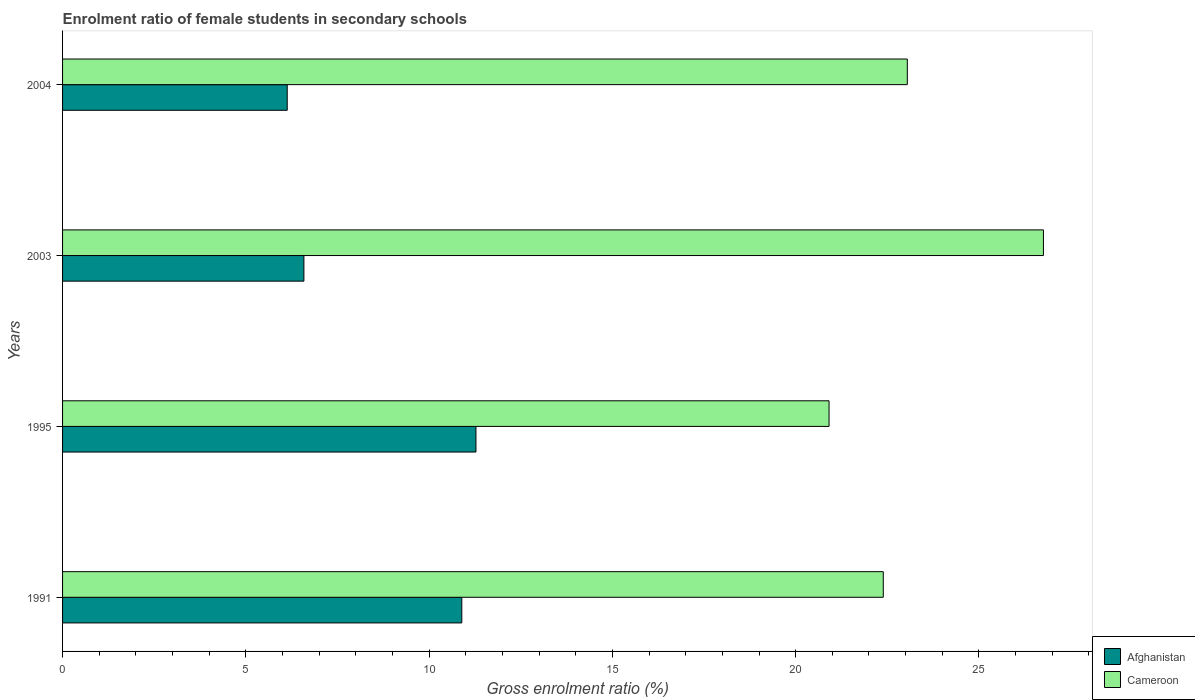How many bars are there on the 3rd tick from the top?
Give a very brief answer. 2. How many bars are there on the 2nd tick from the bottom?
Offer a very short reply. 2. In how many cases, is the number of bars for a given year not equal to the number of legend labels?
Offer a terse response. 0. What is the enrolment ratio of female students in secondary schools in Afghanistan in 1995?
Your answer should be compact. 11.28. Across all years, what is the maximum enrolment ratio of female students in secondary schools in Cameroon?
Keep it short and to the point. 26.76. Across all years, what is the minimum enrolment ratio of female students in secondary schools in Cameroon?
Your answer should be compact. 20.91. What is the total enrolment ratio of female students in secondary schools in Afghanistan in the graph?
Offer a very short reply. 34.88. What is the difference between the enrolment ratio of female students in secondary schools in Cameroon in 1991 and that in 2003?
Ensure brevity in your answer.  -4.37. What is the difference between the enrolment ratio of female students in secondary schools in Afghanistan in 2004 and the enrolment ratio of female students in secondary schools in Cameroon in 1991?
Provide a short and direct response. -16.26. What is the average enrolment ratio of female students in secondary schools in Cameroon per year?
Make the answer very short. 23.28. In the year 2003, what is the difference between the enrolment ratio of female students in secondary schools in Afghanistan and enrolment ratio of female students in secondary schools in Cameroon?
Provide a succinct answer. -20.18. In how many years, is the enrolment ratio of female students in secondary schools in Afghanistan greater than 13 %?
Ensure brevity in your answer.  0. What is the ratio of the enrolment ratio of female students in secondary schools in Afghanistan in 1991 to that in 2004?
Give a very brief answer. 1.78. Is the enrolment ratio of female students in secondary schools in Afghanistan in 1991 less than that in 2003?
Offer a terse response. No. What is the difference between the highest and the second highest enrolment ratio of female students in secondary schools in Afghanistan?
Your response must be concise. 0.39. What is the difference between the highest and the lowest enrolment ratio of female students in secondary schools in Afghanistan?
Offer a very short reply. 5.15. In how many years, is the enrolment ratio of female students in secondary schools in Afghanistan greater than the average enrolment ratio of female students in secondary schools in Afghanistan taken over all years?
Provide a short and direct response. 2. Is the sum of the enrolment ratio of female students in secondary schools in Cameroon in 1991 and 1995 greater than the maximum enrolment ratio of female students in secondary schools in Afghanistan across all years?
Your response must be concise. Yes. What does the 2nd bar from the top in 2003 represents?
Provide a succinct answer. Afghanistan. What does the 2nd bar from the bottom in 1995 represents?
Keep it short and to the point. Cameroon. How many bars are there?
Provide a succinct answer. 8. How many years are there in the graph?
Your response must be concise. 4. Does the graph contain grids?
Offer a very short reply. No. Where does the legend appear in the graph?
Give a very brief answer. Bottom right. What is the title of the graph?
Your answer should be very brief. Enrolment ratio of female students in secondary schools. What is the label or title of the Y-axis?
Ensure brevity in your answer.  Years. What is the Gross enrolment ratio (%) of Afghanistan in 1991?
Your answer should be very brief. 10.89. What is the Gross enrolment ratio (%) in Cameroon in 1991?
Your answer should be compact. 22.39. What is the Gross enrolment ratio (%) in Afghanistan in 1995?
Your response must be concise. 11.28. What is the Gross enrolment ratio (%) in Cameroon in 1995?
Ensure brevity in your answer.  20.91. What is the Gross enrolment ratio (%) in Afghanistan in 2003?
Give a very brief answer. 6.58. What is the Gross enrolment ratio (%) of Cameroon in 2003?
Provide a succinct answer. 26.76. What is the Gross enrolment ratio (%) in Afghanistan in 2004?
Your response must be concise. 6.13. What is the Gross enrolment ratio (%) in Cameroon in 2004?
Your response must be concise. 23.05. Across all years, what is the maximum Gross enrolment ratio (%) in Afghanistan?
Ensure brevity in your answer.  11.28. Across all years, what is the maximum Gross enrolment ratio (%) in Cameroon?
Offer a terse response. 26.76. Across all years, what is the minimum Gross enrolment ratio (%) of Afghanistan?
Your response must be concise. 6.13. Across all years, what is the minimum Gross enrolment ratio (%) of Cameroon?
Give a very brief answer. 20.91. What is the total Gross enrolment ratio (%) of Afghanistan in the graph?
Your answer should be compact. 34.88. What is the total Gross enrolment ratio (%) in Cameroon in the graph?
Give a very brief answer. 93.11. What is the difference between the Gross enrolment ratio (%) of Afghanistan in 1991 and that in 1995?
Offer a terse response. -0.39. What is the difference between the Gross enrolment ratio (%) in Cameroon in 1991 and that in 1995?
Offer a very short reply. 1.48. What is the difference between the Gross enrolment ratio (%) of Afghanistan in 1991 and that in 2003?
Offer a very short reply. 4.31. What is the difference between the Gross enrolment ratio (%) in Cameroon in 1991 and that in 2003?
Your answer should be compact. -4.37. What is the difference between the Gross enrolment ratio (%) of Afghanistan in 1991 and that in 2004?
Offer a terse response. 4.76. What is the difference between the Gross enrolment ratio (%) of Cameroon in 1991 and that in 2004?
Offer a very short reply. -0.66. What is the difference between the Gross enrolment ratio (%) in Afghanistan in 1995 and that in 2003?
Your answer should be compact. 4.69. What is the difference between the Gross enrolment ratio (%) in Cameroon in 1995 and that in 2003?
Offer a very short reply. -5.85. What is the difference between the Gross enrolment ratio (%) in Afghanistan in 1995 and that in 2004?
Provide a succinct answer. 5.15. What is the difference between the Gross enrolment ratio (%) in Cameroon in 1995 and that in 2004?
Your answer should be very brief. -2.14. What is the difference between the Gross enrolment ratio (%) in Afghanistan in 2003 and that in 2004?
Provide a succinct answer. 0.46. What is the difference between the Gross enrolment ratio (%) in Cameroon in 2003 and that in 2004?
Ensure brevity in your answer.  3.71. What is the difference between the Gross enrolment ratio (%) of Afghanistan in 1991 and the Gross enrolment ratio (%) of Cameroon in 1995?
Ensure brevity in your answer.  -10.02. What is the difference between the Gross enrolment ratio (%) in Afghanistan in 1991 and the Gross enrolment ratio (%) in Cameroon in 2003?
Keep it short and to the point. -15.87. What is the difference between the Gross enrolment ratio (%) in Afghanistan in 1991 and the Gross enrolment ratio (%) in Cameroon in 2004?
Offer a terse response. -12.15. What is the difference between the Gross enrolment ratio (%) in Afghanistan in 1995 and the Gross enrolment ratio (%) in Cameroon in 2003?
Provide a short and direct response. -15.48. What is the difference between the Gross enrolment ratio (%) in Afghanistan in 1995 and the Gross enrolment ratio (%) in Cameroon in 2004?
Offer a terse response. -11.77. What is the difference between the Gross enrolment ratio (%) in Afghanistan in 2003 and the Gross enrolment ratio (%) in Cameroon in 2004?
Offer a very short reply. -16.46. What is the average Gross enrolment ratio (%) in Afghanistan per year?
Your answer should be very brief. 8.72. What is the average Gross enrolment ratio (%) of Cameroon per year?
Your answer should be compact. 23.28. In the year 1991, what is the difference between the Gross enrolment ratio (%) in Afghanistan and Gross enrolment ratio (%) in Cameroon?
Your answer should be compact. -11.5. In the year 1995, what is the difference between the Gross enrolment ratio (%) in Afghanistan and Gross enrolment ratio (%) in Cameroon?
Give a very brief answer. -9.63. In the year 2003, what is the difference between the Gross enrolment ratio (%) in Afghanistan and Gross enrolment ratio (%) in Cameroon?
Offer a terse response. -20.18. In the year 2004, what is the difference between the Gross enrolment ratio (%) in Afghanistan and Gross enrolment ratio (%) in Cameroon?
Offer a very short reply. -16.92. What is the ratio of the Gross enrolment ratio (%) of Afghanistan in 1991 to that in 1995?
Provide a short and direct response. 0.97. What is the ratio of the Gross enrolment ratio (%) of Cameroon in 1991 to that in 1995?
Ensure brevity in your answer.  1.07. What is the ratio of the Gross enrolment ratio (%) in Afghanistan in 1991 to that in 2003?
Give a very brief answer. 1.65. What is the ratio of the Gross enrolment ratio (%) of Cameroon in 1991 to that in 2003?
Make the answer very short. 0.84. What is the ratio of the Gross enrolment ratio (%) in Afghanistan in 1991 to that in 2004?
Provide a succinct answer. 1.78. What is the ratio of the Gross enrolment ratio (%) in Cameroon in 1991 to that in 2004?
Your response must be concise. 0.97. What is the ratio of the Gross enrolment ratio (%) of Afghanistan in 1995 to that in 2003?
Keep it short and to the point. 1.71. What is the ratio of the Gross enrolment ratio (%) in Cameroon in 1995 to that in 2003?
Offer a very short reply. 0.78. What is the ratio of the Gross enrolment ratio (%) of Afghanistan in 1995 to that in 2004?
Keep it short and to the point. 1.84. What is the ratio of the Gross enrolment ratio (%) of Cameroon in 1995 to that in 2004?
Your answer should be compact. 0.91. What is the ratio of the Gross enrolment ratio (%) in Afghanistan in 2003 to that in 2004?
Provide a short and direct response. 1.07. What is the ratio of the Gross enrolment ratio (%) in Cameroon in 2003 to that in 2004?
Your answer should be compact. 1.16. What is the difference between the highest and the second highest Gross enrolment ratio (%) in Afghanistan?
Your answer should be compact. 0.39. What is the difference between the highest and the second highest Gross enrolment ratio (%) in Cameroon?
Keep it short and to the point. 3.71. What is the difference between the highest and the lowest Gross enrolment ratio (%) in Afghanistan?
Your response must be concise. 5.15. What is the difference between the highest and the lowest Gross enrolment ratio (%) of Cameroon?
Offer a terse response. 5.85. 